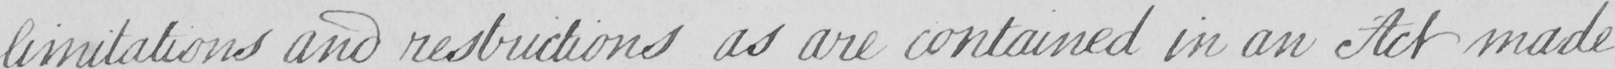Can you read and transcribe this handwriting? limitations and restrictions as are contained in an Act made 